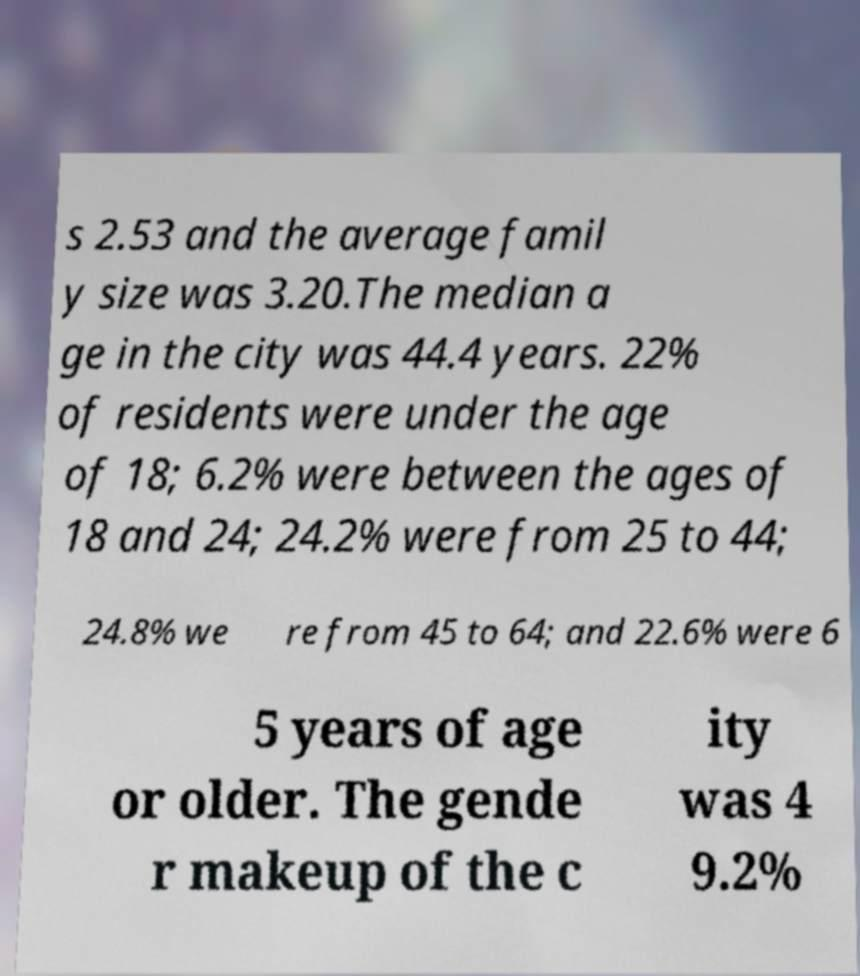Could you extract and type out the text from this image? s 2.53 and the average famil y size was 3.20.The median a ge in the city was 44.4 years. 22% of residents were under the age of 18; 6.2% were between the ages of 18 and 24; 24.2% were from 25 to 44; 24.8% we re from 45 to 64; and 22.6% were 6 5 years of age or older. The gende r makeup of the c ity was 4 9.2% 